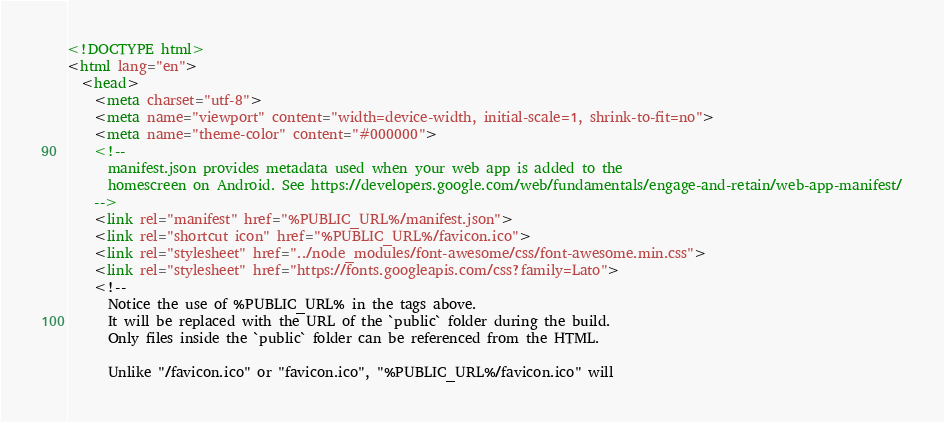Convert code to text. <code><loc_0><loc_0><loc_500><loc_500><_HTML_><!DOCTYPE html>
<html lang="en">
  <head>
    <meta charset="utf-8">
    <meta name="viewport" content="width=device-width, initial-scale=1, shrink-to-fit=no">
    <meta name="theme-color" content="#000000">
    <!--
      manifest.json provides metadata used when your web app is added to the
      homescreen on Android. See https://developers.google.com/web/fundamentals/engage-and-retain/web-app-manifest/
    -->
    <link rel="manifest" href="%PUBLIC_URL%/manifest.json">
    <link rel="shortcut icon" href="%PUBLIC_URL%/favicon.ico">
    <link rel="stylesheet" href="../node_modules/font-awesome/css/font-awesome.min.css">
    <link rel="stylesheet" href="https://fonts.googleapis.com/css?family=Lato">
    <!--
      Notice the use of %PUBLIC_URL% in the tags above.
      It will be replaced with the URL of the `public` folder during the build.
      Only files inside the `public` folder can be referenced from the HTML.

      Unlike "/favicon.ico" or "favicon.ico", "%PUBLIC_URL%/favicon.ico" will</code> 